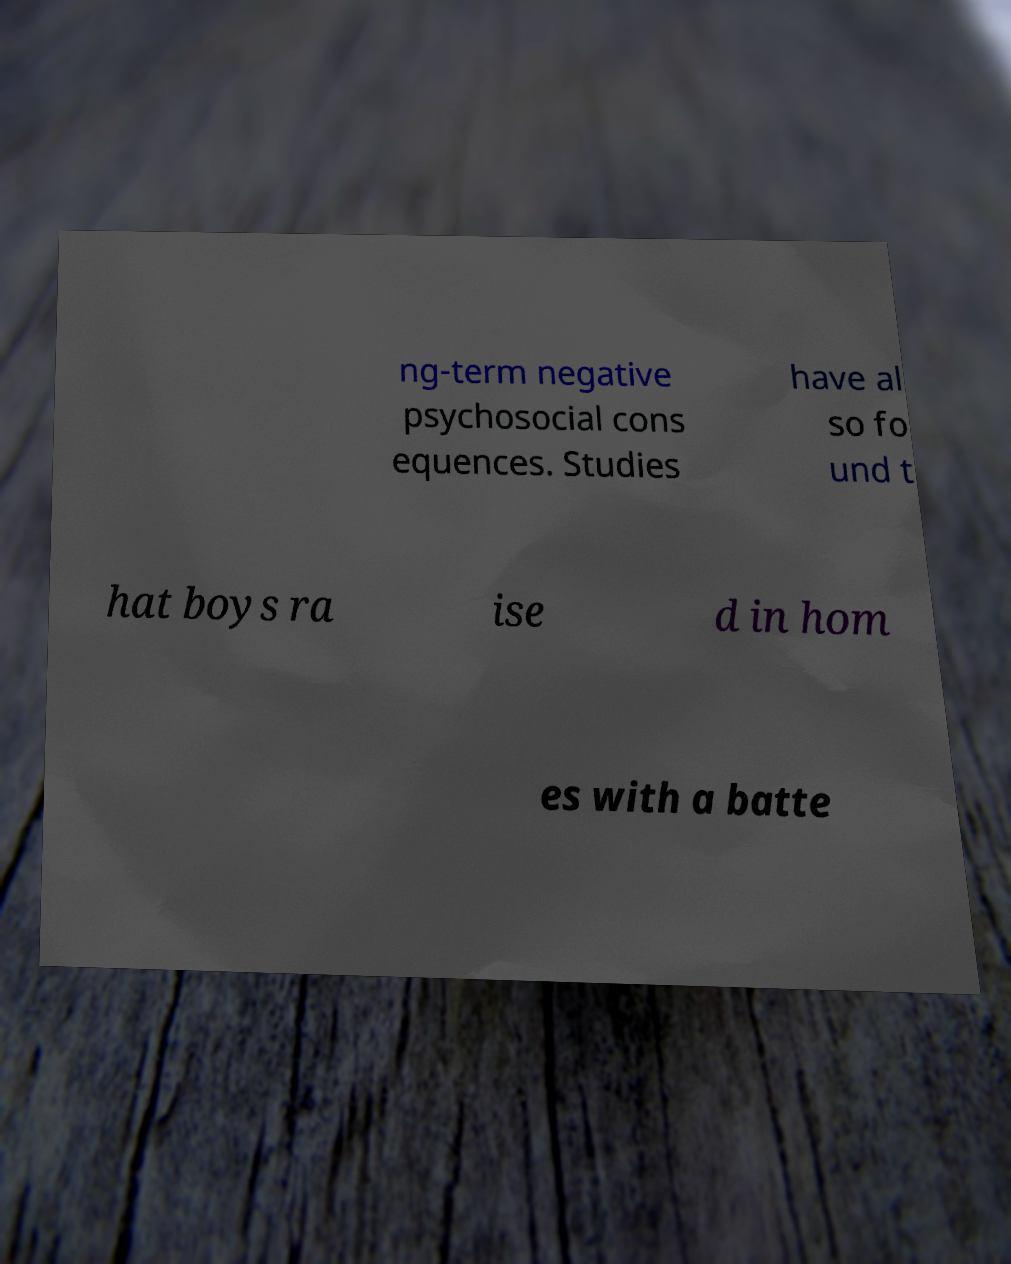Can you read and provide the text displayed in the image?This photo seems to have some interesting text. Can you extract and type it out for me? ng-term negative psychosocial cons equences. Studies have al so fo und t hat boys ra ise d in hom es with a batte 